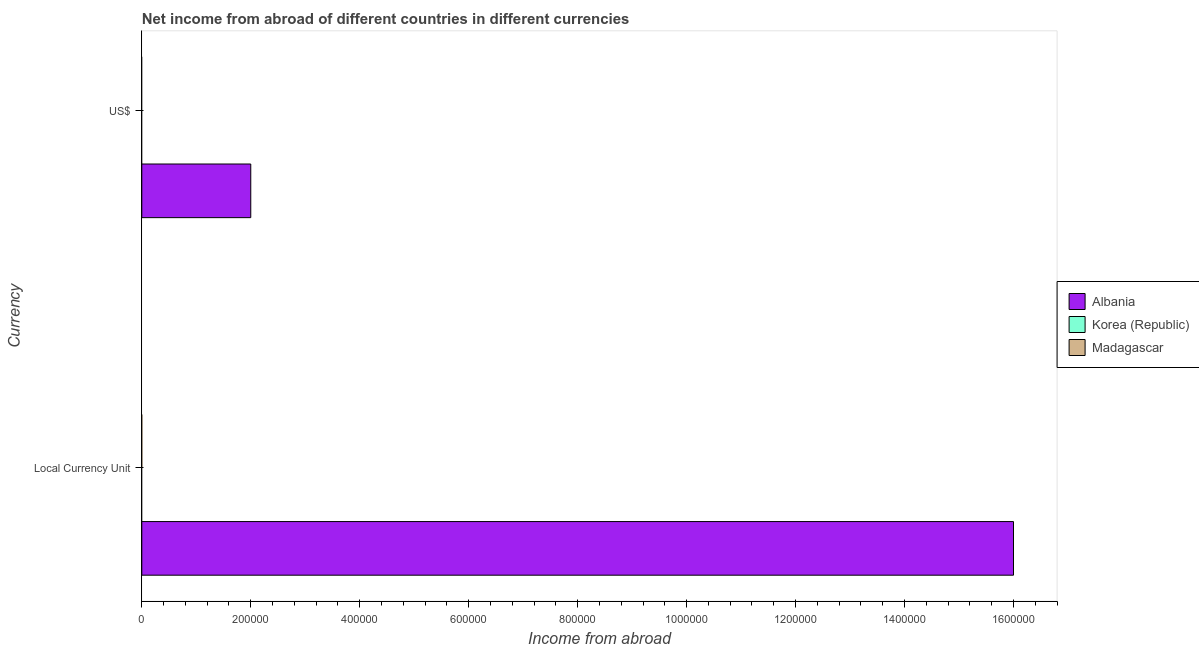What is the label of the 2nd group of bars from the top?
Ensure brevity in your answer.  Local Currency Unit. What is the income from abroad in constant 2005 us$ in Albania?
Your response must be concise. 1.60e+06. Across all countries, what is the maximum income from abroad in constant 2005 us$?
Give a very brief answer. 1.60e+06. Across all countries, what is the minimum income from abroad in constant 2005 us$?
Provide a short and direct response. 0. In which country was the income from abroad in us$ maximum?
Your answer should be compact. Albania. What is the total income from abroad in constant 2005 us$ in the graph?
Make the answer very short. 1.60e+06. What is the difference between the income from abroad in us$ in Albania and the income from abroad in constant 2005 us$ in Madagascar?
Ensure brevity in your answer.  2.00e+05. What is the average income from abroad in us$ per country?
Keep it short and to the point. 6.67e+04. What is the difference between the income from abroad in us$ and income from abroad in constant 2005 us$ in Albania?
Your answer should be compact. -1.40e+06. In how many countries, is the income from abroad in us$ greater than 840000 units?
Your answer should be very brief. 0. How many bars are there?
Make the answer very short. 2. How many countries are there in the graph?
Provide a succinct answer. 3. Are the values on the major ticks of X-axis written in scientific E-notation?
Provide a short and direct response. No. What is the title of the graph?
Offer a very short reply. Net income from abroad of different countries in different currencies. What is the label or title of the X-axis?
Provide a succinct answer. Income from abroad. What is the label or title of the Y-axis?
Keep it short and to the point. Currency. What is the Income from abroad of Albania in Local Currency Unit?
Your answer should be very brief. 1.60e+06. What is the Income from abroad in Madagascar in Local Currency Unit?
Your answer should be compact. 0. What is the Income from abroad in Korea (Republic) in US$?
Give a very brief answer. 0. What is the Income from abroad in Madagascar in US$?
Your answer should be very brief. 0. Across all Currency, what is the maximum Income from abroad of Albania?
Ensure brevity in your answer.  1.60e+06. Across all Currency, what is the minimum Income from abroad in Albania?
Give a very brief answer. 2.00e+05. What is the total Income from abroad of Albania in the graph?
Keep it short and to the point. 1.80e+06. What is the difference between the Income from abroad of Albania in Local Currency Unit and that in US$?
Your response must be concise. 1.40e+06. What is the average Income from abroad of Albania per Currency?
Provide a short and direct response. 9.00e+05. What is the average Income from abroad in Madagascar per Currency?
Your answer should be very brief. 0. What is the ratio of the Income from abroad of Albania in Local Currency Unit to that in US$?
Your answer should be compact. 8. What is the difference between the highest and the second highest Income from abroad in Albania?
Provide a short and direct response. 1.40e+06. What is the difference between the highest and the lowest Income from abroad of Albania?
Your response must be concise. 1.40e+06. 